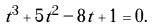<formula> <loc_0><loc_0><loc_500><loc_500>t ^ { 3 } + 5 t ^ { 2 } - 8 t + 1 = 0 .</formula> 